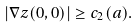<formula> <loc_0><loc_0><loc_500><loc_500>| \nabla z ( 0 , 0 ) | \geq c _ { 2 } ( a ) .</formula> 